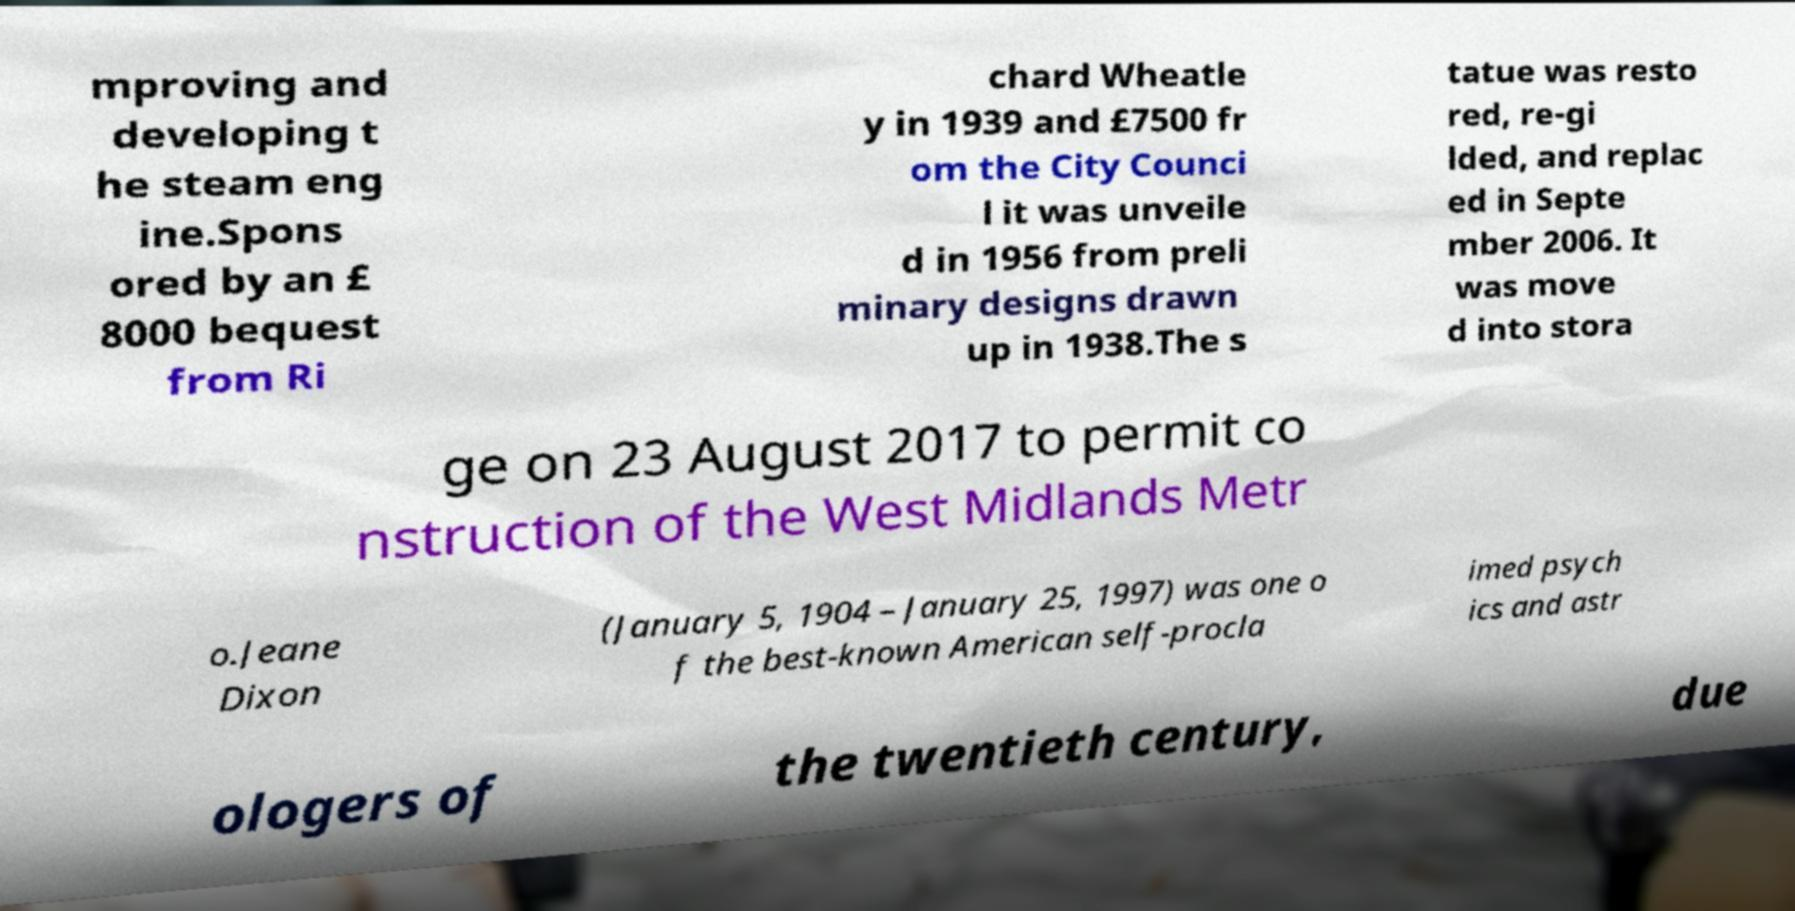For documentation purposes, I need the text within this image transcribed. Could you provide that? mproving and developing t he steam eng ine.Spons ored by an £ 8000 bequest from Ri chard Wheatle y in 1939 and £7500 fr om the City Counci l it was unveile d in 1956 from preli minary designs drawn up in 1938.The s tatue was resto red, re-gi lded, and replac ed in Septe mber 2006. It was move d into stora ge on 23 August 2017 to permit co nstruction of the West Midlands Metr o.Jeane Dixon (January 5, 1904 – January 25, 1997) was one o f the best-known American self-procla imed psych ics and astr ologers of the twentieth century, due 